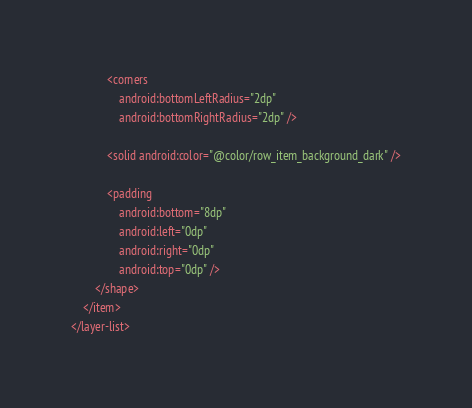<code> <loc_0><loc_0><loc_500><loc_500><_XML_>            <corners
                android:bottomLeftRadius="2dp"
                android:bottomRightRadius="2dp" />

            <solid android:color="@color/row_item_background_dark" />

            <padding
                android:bottom="8dp"
                android:left="0dp"
                android:right="0dp"
                android:top="0dp" />
        </shape>
    </item>
</layer-list></code> 